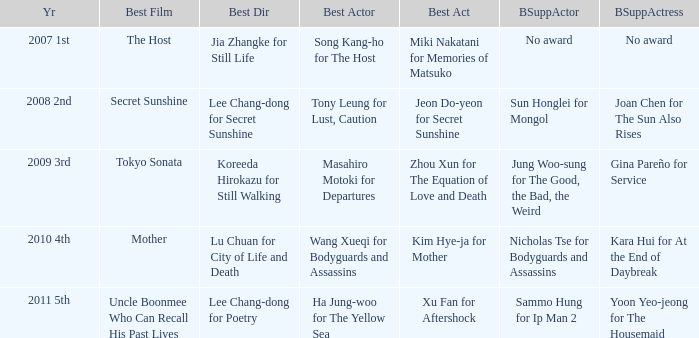Name the best actor for uncle boonmee who can recall his past lives Ha Jung-woo for The Yellow Sea. 